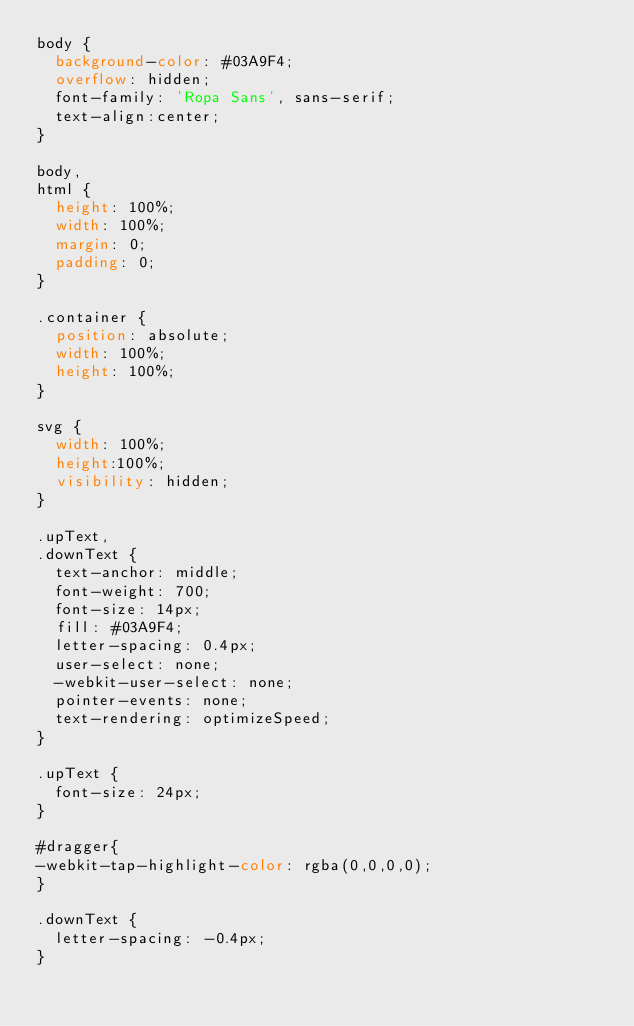Convert code to text. <code><loc_0><loc_0><loc_500><loc_500><_CSS_>body {
  background-color: #03A9F4;
  overflow: hidden;
  font-family: 'Ropa Sans', sans-serif;
  text-align:center;
}

body,
html {
  height: 100%;
  width: 100%;
  margin: 0;
  padding: 0;
}

.container {
  position: absolute;
  width: 100%;
  height: 100%;
}

svg {
  width: 100%;
  height:100%;
  visibility: hidden;
}

.upText,
.downText {
  text-anchor: middle;
  font-weight: 700;
  font-size: 14px;
  fill: #03A9F4;
  letter-spacing: 0.4px;
  user-select: none;
  -webkit-user-select: none;
  pointer-events: none;
  text-rendering: optimizeSpeed;
}

.upText {
  font-size: 24px;
}

#dragger{
-webkit-tap-highlight-color: rgba(0,0,0,0); 
}

.downText {
  letter-spacing: -0.4px;
}</code> 